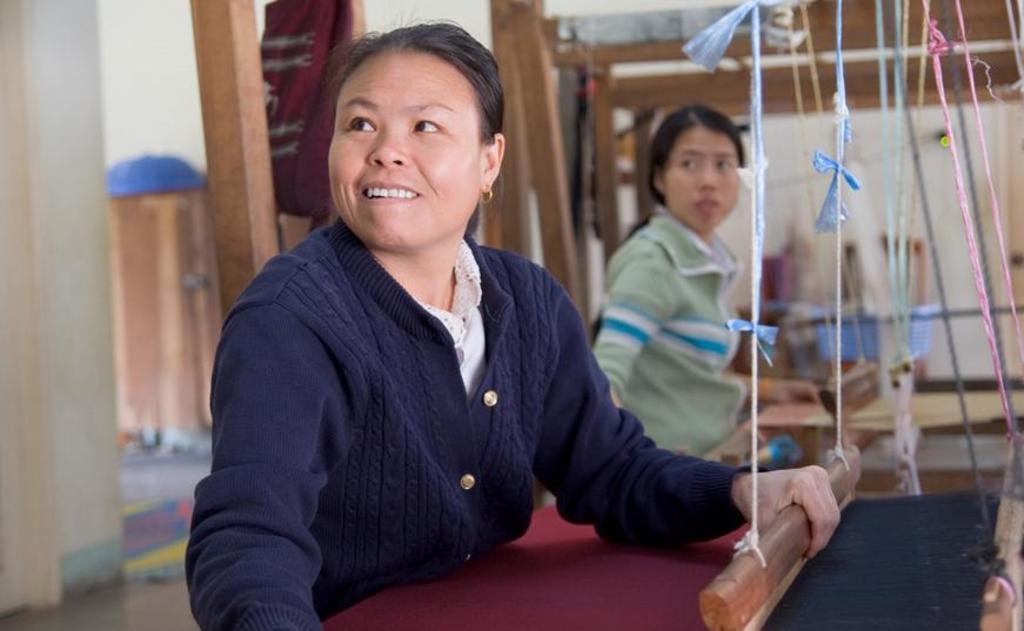In one or two sentences, can you explain what this image depicts? In this picture we can see a woman loom weaving. There is another person and a few objects are visible in the background. 